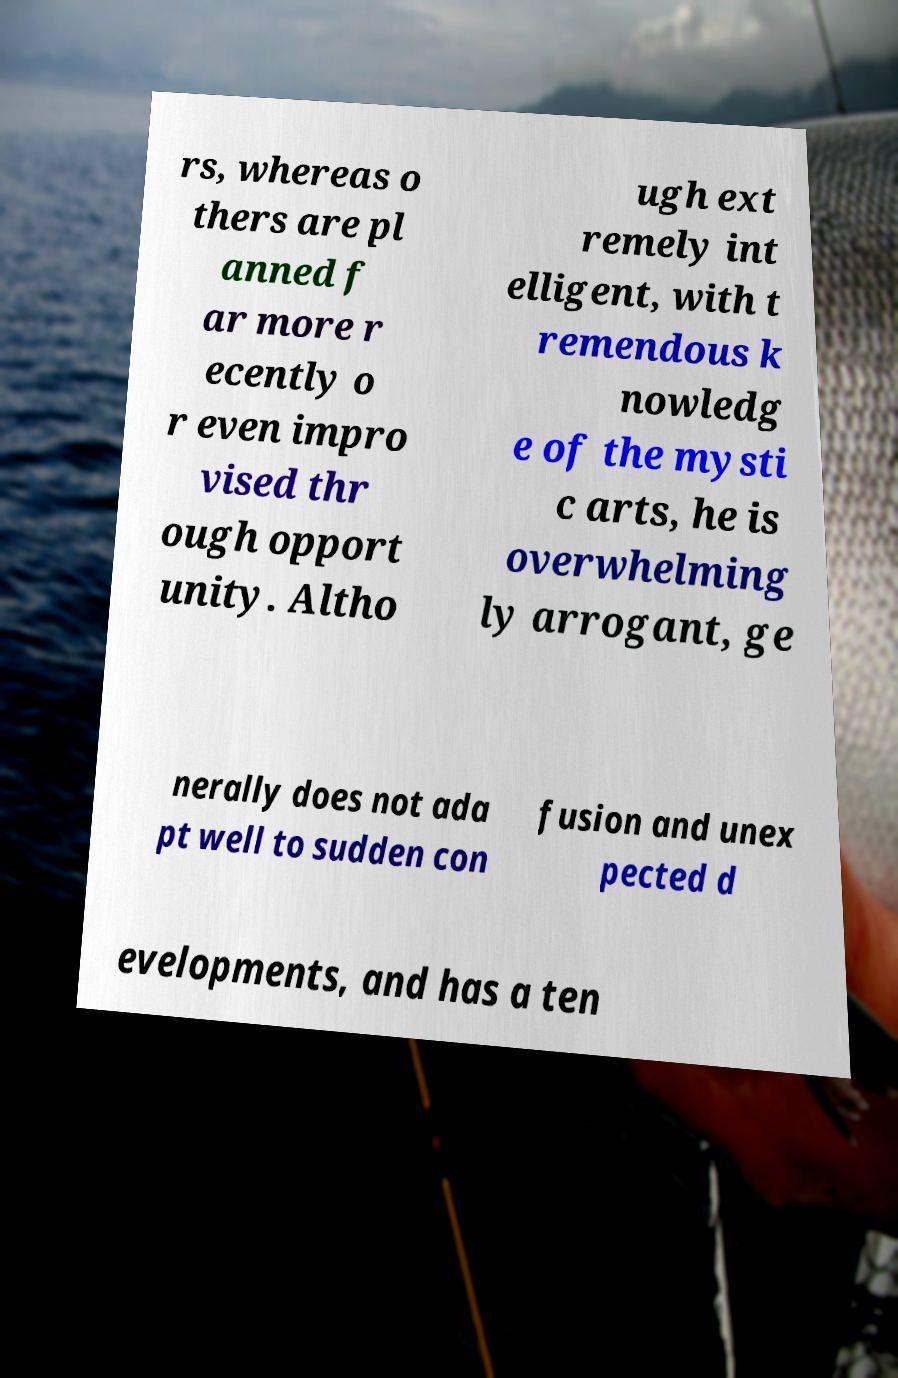What messages or text are displayed in this image? I need them in a readable, typed format. rs, whereas o thers are pl anned f ar more r ecently o r even impro vised thr ough opport unity. Altho ugh ext remely int elligent, with t remendous k nowledg e of the mysti c arts, he is overwhelming ly arrogant, ge nerally does not ada pt well to sudden con fusion and unex pected d evelopments, and has a ten 